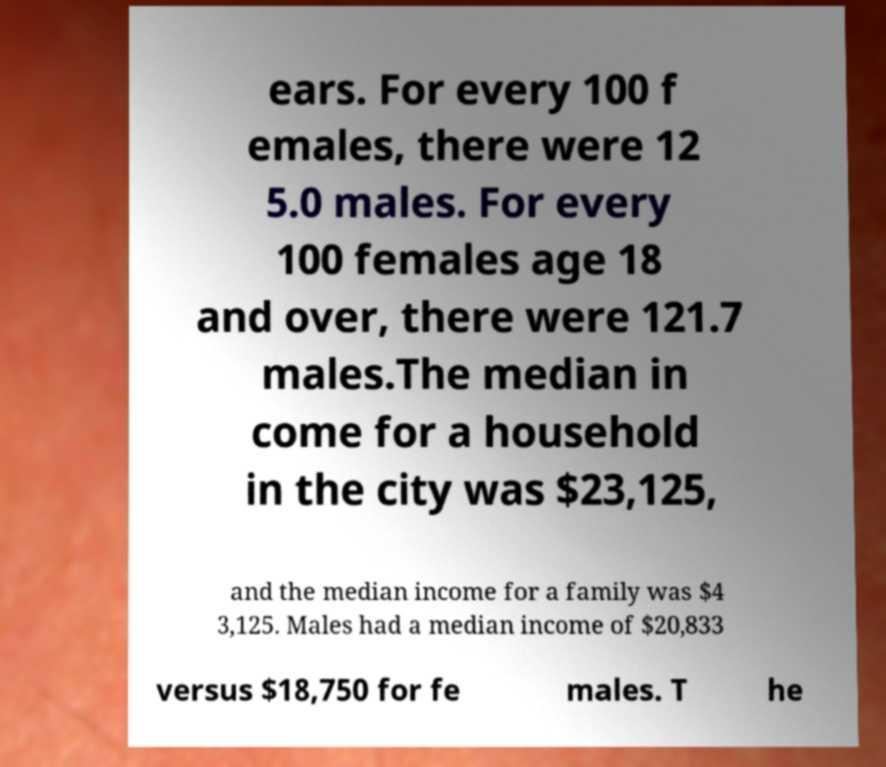Please read and relay the text visible in this image. What does it say? ears. For every 100 f emales, there were 12 5.0 males. For every 100 females age 18 and over, there were 121.7 males.The median in come for a household in the city was $23,125, and the median income for a family was $4 3,125. Males had a median income of $20,833 versus $18,750 for fe males. T he 